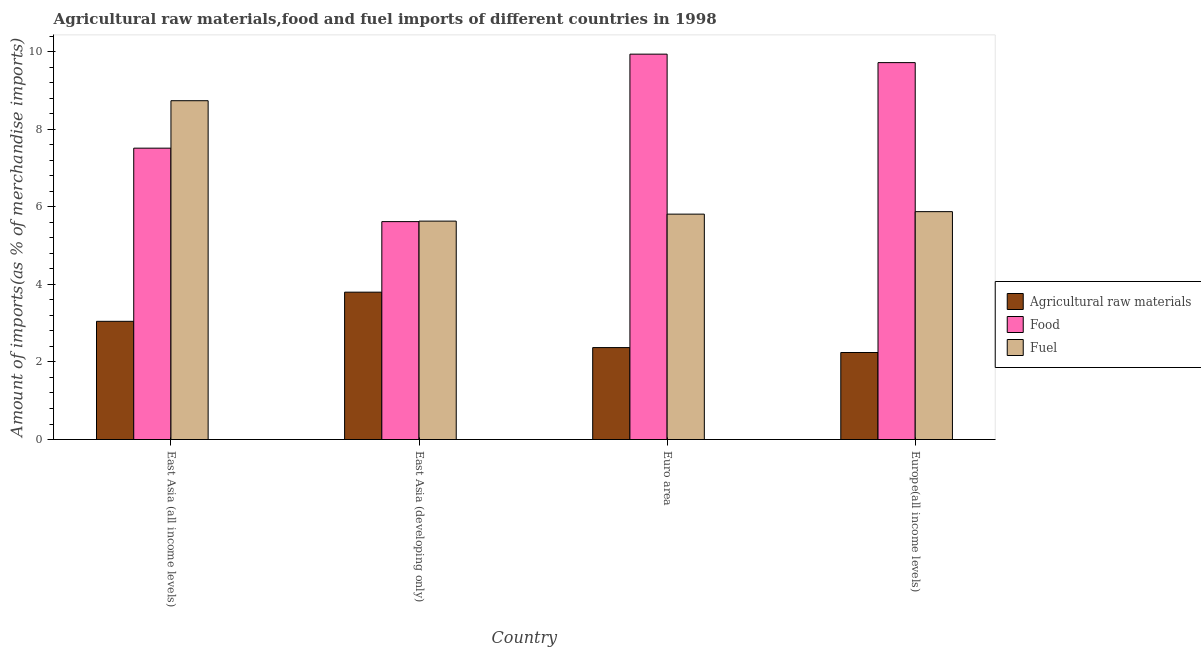How many different coloured bars are there?
Make the answer very short. 3. How many groups of bars are there?
Offer a very short reply. 4. Are the number of bars per tick equal to the number of legend labels?
Your answer should be very brief. Yes. Are the number of bars on each tick of the X-axis equal?
Provide a short and direct response. Yes. How many bars are there on the 4th tick from the left?
Give a very brief answer. 3. How many bars are there on the 2nd tick from the right?
Offer a very short reply. 3. What is the label of the 2nd group of bars from the left?
Your answer should be very brief. East Asia (developing only). What is the percentage of fuel imports in East Asia (all income levels)?
Offer a very short reply. 8.74. Across all countries, what is the maximum percentage of fuel imports?
Ensure brevity in your answer.  8.74. Across all countries, what is the minimum percentage of fuel imports?
Your answer should be compact. 5.63. In which country was the percentage of raw materials imports maximum?
Ensure brevity in your answer.  East Asia (developing only). In which country was the percentage of raw materials imports minimum?
Offer a very short reply. Europe(all income levels). What is the total percentage of food imports in the graph?
Offer a terse response. 32.8. What is the difference between the percentage of fuel imports in East Asia (all income levels) and that in East Asia (developing only)?
Your response must be concise. 3.11. What is the difference between the percentage of raw materials imports in East Asia (developing only) and the percentage of fuel imports in Europe(all income levels)?
Your answer should be very brief. -2.08. What is the average percentage of raw materials imports per country?
Your answer should be very brief. 2.87. What is the difference between the percentage of fuel imports and percentage of food imports in East Asia (developing only)?
Ensure brevity in your answer.  0.01. What is the ratio of the percentage of fuel imports in East Asia (all income levels) to that in East Asia (developing only)?
Give a very brief answer. 1.55. What is the difference between the highest and the second highest percentage of raw materials imports?
Provide a short and direct response. 0.75. What is the difference between the highest and the lowest percentage of raw materials imports?
Make the answer very short. 1.56. Is the sum of the percentage of food imports in East Asia (all income levels) and Euro area greater than the maximum percentage of fuel imports across all countries?
Your answer should be very brief. Yes. What does the 2nd bar from the left in East Asia (developing only) represents?
Make the answer very short. Food. What does the 1st bar from the right in Euro area represents?
Offer a very short reply. Fuel. Is it the case that in every country, the sum of the percentage of raw materials imports and percentage of food imports is greater than the percentage of fuel imports?
Give a very brief answer. Yes. How many bars are there?
Give a very brief answer. 12. Are all the bars in the graph horizontal?
Keep it short and to the point. No. What is the difference between two consecutive major ticks on the Y-axis?
Give a very brief answer. 2. Are the values on the major ticks of Y-axis written in scientific E-notation?
Ensure brevity in your answer.  No. Does the graph contain grids?
Give a very brief answer. No. How are the legend labels stacked?
Ensure brevity in your answer.  Vertical. What is the title of the graph?
Offer a very short reply. Agricultural raw materials,food and fuel imports of different countries in 1998. What is the label or title of the X-axis?
Offer a very short reply. Country. What is the label or title of the Y-axis?
Make the answer very short. Amount of imports(as % of merchandise imports). What is the Amount of imports(as % of merchandise imports) of Agricultural raw materials in East Asia (all income levels)?
Provide a short and direct response. 3.05. What is the Amount of imports(as % of merchandise imports) in Food in East Asia (all income levels)?
Ensure brevity in your answer.  7.52. What is the Amount of imports(as % of merchandise imports) of Fuel in East Asia (all income levels)?
Keep it short and to the point. 8.74. What is the Amount of imports(as % of merchandise imports) of Agricultural raw materials in East Asia (developing only)?
Give a very brief answer. 3.8. What is the Amount of imports(as % of merchandise imports) in Food in East Asia (developing only)?
Keep it short and to the point. 5.62. What is the Amount of imports(as % of merchandise imports) of Fuel in East Asia (developing only)?
Your answer should be very brief. 5.63. What is the Amount of imports(as % of merchandise imports) in Agricultural raw materials in Euro area?
Make the answer very short. 2.37. What is the Amount of imports(as % of merchandise imports) of Food in Euro area?
Ensure brevity in your answer.  9.94. What is the Amount of imports(as % of merchandise imports) of Fuel in Euro area?
Ensure brevity in your answer.  5.81. What is the Amount of imports(as % of merchandise imports) in Agricultural raw materials in Europe(all income levels)?
Your answer should be very brief. 2.24. What is the Amount of imports(as % of merchandise imports) in Food in Europe(all income levels)?
Your answer should be very brief. 9.72. What is the Amount of imports(as % of merchandise imports) of Fuel in Europe(all income levels)?
Provide a succinct answer. 5.88. Across all countries, what is the maximum Amount of imports(as % of merchandise imports) of Agricultural raw materials?
Make the answer very short. 3.8. Across all countries, what is the maximum Amount of imports(as % of merchandise imports) of Food?
Give a very brief answer. 9.94. Across all countries, what is the maximum Amount of imports(as % of merchandise imports) of Fuel?
Give a very brief answer. 8.74. Across all countries, what is the minimum Amount of imports(as % of merchandise imports) of Agricultural raw materials?
Offer a terse response. 2.24. Across all countries, what is the minimum Amount of imports(as % of merchandise imports) of Food?
Give a very brief answer. 5.62. Across all countries, what is the minimum Amount of imports(as % of merchandise imports) of Fuel?
Keep it short and to the point. 5.63. What is the total Amount of imports(as % of merchandise imports) of Agricultural raw materials in the graph?
Your response must be concise. 11.46. What is the total Amount of imports(as % of merchandise imports) of Food in the graph?
Offer a terse response. 32.8. What is the total Amount of imports(as % of merchandise imports) in Fuel in the graph?
Offer a very short reply. 26.06. What is the difference between the Amount of imports(as % of merchandise imports) in Agricultural raw materials in East Asia (all income levels) and that in East Asia (developing only)?
Your response must be concise. -0.75. What is the difference between the Amount of imports(as % of merchandise imports) in Food in East Asia (all income levels) and that in East Asia (developing only)?
Provide a succinct answer. 1.89. What is the difference between the Amount of imports(as % of merchandise imports) of Fuel in East Asia (all income levels) and that in East Asia (developing only)?
Provide a succinct answer. 3.11. What is the difference between the Amount of imports(as % of merchandise imports) in Agricultural raw materials in East Asia (all income levels) and that in Euro area?
Provide a short and direct response. 0.68. What is the difference between the Amount of imports(as % of merchandise imports) of Food in East Asia (all income levels) and that in Euro area?
Offer a terse response. -2.43. What is the difference between the Amount of imports(as % of merchandise imports) in Fuel in East Asia (all income levels) and that in Euro area?
Provide a succinct answer. 2.93. What is the difference between the Amount of imports(as % of merchandise imports) in Agricultural raw materials in East Asia (all income levels) and that in Europe(all income levels)?
Offer a terse response. 0.8. What is the difference between the Amount of imports(as % of merchandise imports) of Food in East Asia (all income levels) and that in Europe(all income levels)?
Give a very brief answer. -2.21. What is the difference between the Amount of imports(as % of merchandise imports) in Fuel in East Asia (all income levels) and that in Europe(all income levels)?
Ensure brevity in your answer.  2.86. What is the difference between the Amount of imports(as % of merchandise imports) of Agricultural raw materials in East Asia (developing only) and that in Euro area?
Offer a very short reply. 1.43. What is the difference between the Amount of imports(as % of merchandise imports) of Food in East Asia (developing only) and that in Euro area?
Provide a short and direct response. -4.32. What is the difference between the Amount of imports(as % of merchandise imports) of Fuel in East Asia (developing only) and that in Euro area?
Offer a very short reply. -0.18. What is the difference between the Amount of imports(as % of merchandise imports) of Agricultural raw materials in East Asia (developing only) and that in Europe(all income levels)?
Offer a very short reply. 1.56. What is the difference between the Amount of imports(as % of merchandise imports) in Food in East Asia (developing only) and that in Europe(all income levels)?
Your response must be concise. -4.1. What is the difference between the Amount of imports(as % of merchandise imports) of Fuel in East Asia (developing only) and that in Europe(all income levels)?
Give a very brief answer. -0.24. What is the difference between the Amount of imports(as % of merchandise imports) of Agricultural raw materials in Euro area and that in Europe(all income levels)?
Provide a succinct answer. 0.13. What is the difference between the Amount of imports(as % of merchandise imports) in Food in Euro area and that in Europe(all income levels)?
Make the answer very short. 0.22. What is the difference between the Amount of imports(as % of merchandise imports) of Fuel in Euro area and that in Europe(all income levels)?
Your answer should be compact. -0.06. What is the difference between the Amount of imports(as % of merchandise imports) of Agricultural raw materials in East Asia (all income levels) and the Amount of imports(as % of merchandise imports) of Food in East Asia (developing only)?
Give a very brief answer. -2.57. What is the difference between the Amount of imports(as % of merchandise imports) of Agricultural raw materials in East Asia (all income levels) and the Amount of imports(as % of merchandise imports) of Fuel in East Asia (developing only)?
Offer a very short reply. -2.58. What is the difference between the Amount of imports(as % of merchandise imports) in Food in East Asia (all income levels) and the Amount of imports(as % of merchandise imports) in Fuel in East Asia (developing only)?
Give a very brief answer. 1.88. What is the difference between the Amount of imports(as % of merchandise imports) of Agricultural raw materials in East Asia (all income levels) and the Amount of imports(as % of merchandise imports) of Food in Euro area?
Provide a short and direct response. -6.89. What is the difference between the Amount of imports(as % of merchandise imports) in Agricultural raw materials in East Asia (all income levels) and the Amount of imports(as % of merchandise imports) in Fuel in Euro area?
Provide a succinct answer. -2.77. What is the difference between the Amount of imports(as % of merchandise imports) in Food in East Asia (all income levels) and the Amount of imports(as % of merchandise imports) in Fuel in Euro area?
Offer a terse response. 1.7. What is the difference between the Amount of imports(as % of merchandise imports) of Agricultural raw materials in East Asia (all income levels) and the Amount of imports(as % of merchandise imports) of Food in Europe(all income levels)?
Provide a succinct answer. -6.67. What is the difference between the Amount of imports(as % of merchandise imports) of Agricultural raw materials in East Asia (all income levels) and the Amount of imports(as % of merchandise imports) of Fuel in Europe(all income levels)?
Offer a very short reply. -2.83. What is the difference between the Amount of imports(as % of merchandise imports) in Food in East Asia (all income levels) and the Amount of imports(as % of merchandise imports) in Fuel in Europe(all income levels)?
Your response must be concise. 1.64. What is the difference between the Amount of imports(as % of merchandise imports) of Agricultural raw materials in East Asia (developing only) and the Amount of imports(as % of merchandise imports) of Food in Euro area?
Provide a succinct answer. -6.14. What is the difference between the Amount of imports(as % of merchandise imports) in Agricultural raw materials in East Asia (developing only) and the Amount of imports(as % of merchandise imports) in Fuel in Euro area?
Make the answer very short. -2.01. What is the difference between the Amount of imports(as % of merchandise imports) in Food in East Asia (developing only) and the Amount of imports(as % of merchandise imports) in Fuel in Euro area?
Keep it short and to the point. -0.19. What is the difference between the Amount of imports(as % of merchandise imports) in Agricultural raw materials in East Asia (developing only) and the Amount of imports(as % of merchandise imports) in Food in Europe(all income levels)?
Make the answer very short. -5.92. What is the difference between the Amount of imports(as % of merchandise imports) of Agricultural raw materials in East Asia (developing only) and the Amount of imports(as % of merchandise imports) of Fuel in Europe(all income levels)?
Offer a terse response. -2.08. What is the difference between the Amount of imports(as % of merchandise imports) in Food in East Asia (developing only) and the Amount of imports(as % of merchandise imports) in Fuel in Europe(all income levels)?
Your response must be concise. -0.26. What is the difference between the Amount of imports(as % of merchandise imports) in Agricultural raw materials in Euro area and the Amount of imports(as % of merchandise imports) in Food in Europe(all income levels)?
Ensure brevity in your answer.  -7.35. What is the difference between the Amount of imports(as % of merchandise imports) in Agricultural raw materials in Euro area and the Amount of imports(as % of merchandise imports) in Fuel in Europe(all income levels)?
Offer a terse response. -3.51. What is the difference between the Amount of imports(as % of merchandise imports) in Food in Euro area and the Amount of imports(as % of merchandise imports) in Fuel in Europe(all income levels)?
Your answer should be compact. 4.06. What is the average Amount of imports(as % of merchandise imports) in Agricultural raw materials per country?
Keep it short and to the point. 2.87. What is the average Amount of imports(as % of merchandise imports) of Food per country?
Offer a terse response. 8.2. What is the average Amount of imports(as % of merchandise imports) in Fuel per country?
Provide a short and direct response. 6.52. What is the difference between the Amount of imports(as % of merchandise imports) in Agricultural raw materials and Amount of imports(as % of merchandise imports) in Food in East Asia (all income levels)?
Give a very brief answer. -4.47. What is the difference between the Amount of imports(as % of merchandise imports) in Agricultural raw materials and Amount of imports(as % of merchandise imports) in Fuel in East Asia (all income levels)?
Ensure brevity in your answer.  -5.69. What is the difference between the Amount of imports(as % of merchandise imports) of Food and Amount of imports(as % of merchandise imports) of Fuel in East Asia (all income levels)?
Give a very brief answer. -1.22. What is the difference between the Amount of imports(as % of merchandise imports) in Agricultural raw materials and Amount of imports(as % of merchandise imports) in Food in East Asia (developing only)?
Offer a terse response. -1.82. What is the difference between the Amount of imports(as % of merchandise imports) in Agricultural raw materials and Amount of imports(as % of merchandise imports) in Fuel in East Asia (developing only)?
Give a very brief answer. -1.83. What is the difference between the Amount of imports(as % of merchandise imports) in Food and Amount of imports(as % of merchandise imports) in Fuel in East Asia (developing only)?
Give a very brief answer. -0.01. What is the difference between the Amount of imports(as % of merchandise imports) in Agricultural raw materials and Amount of imports(as % of merchandise imports) in Food in Euro area?
Offer a very short reply. -7.57. What is the difference between the Amount of imports(as % of merchandise imports) in Agricultural raw materials and Amount of imports(as % of merchandise imports) in Fuel in Euro area?
Your response must be concise. -3.44. What is the difference between the Amount of imports(as % of merchandise imports) of Food and Amount of imports(as % of merchandise imports) of Fuel in Euro area?
Provide a succinct answer. 4.13. What is the difference between the Amount of imports(as % of merchandise imports) of Agricultural raw materials and Amount of imports(as % of merchandise imports) of Food in Europe(all income levels)?
Ensure brevity in your answer.  -7.48. What is the difference between the Amount of imports(as % of merchandise imports) in Agricultural raw materials and Amount of imports(as % of merchandise imports) in Fuel in Europe(all income levels)?
Offer a terse response. -3.63. What is the difference between the Amount of imports(as % of merchandise imports) in Food and Amount of imports(as % of merchandise imports) in Fuel in Europe(all income levels)?
Offer a very short reply. 3.84. What is the ratio of the Amount of imports(as % of merchandise imports) of Agricultural raw materials in East Asia (all income levels) to that in East Asia (developing only)?
Offer a terse response. 0.8. What is the ratio of the Amount of imports(as % of merchandise imports) in Food in East Asia (all income levels) to that in East Asia (developing only)?
Keep it short and to the point. 1.34. What is the ratio of the Amount of imports(as % of merchandise imports) of Fuel in East Asia (all income levels) to that in East Asia (developing only)?
Give a very brief answer. 1.55. What is the ratio of the Amount of imports(as % of merchandise imports) of Agricultural raw materials in East Asia (all income levels) to that in Euro area?
Provide a succinct answer. 1.29. What is the ratio of the Amount of imports(as % of merchandise imports) of Food in East Asia (all income levels) to that in Euro area?
Your answer should be very brief. 0.76. What is the ratio of the Amount of imports(as % of merchandise imports) in Fuel in East Asia (all income levels) to that in Euro area?
Make the answer very short. 1.5. What is the ratio of the Amount of imports(as % of merchandise imports) of Agricultural raw materials in East Asia (all income levels) to that in Europe(all income levels)?
Your answer should be very brief. 1.36. What is the ratio of the Amount of imports(as % of merchandise imports) of Food in East Asia (all income levels) to that in Europe(all income levels)?
Offer a terse response. 0.77. What is the ratio of the Amount of imports(as % of merchandise imports) in Fuel in East Asia (all income levels) to that in Europe(all income levels)?
Your answer should be very brief. 1.49. What is the ratio of the Amount of imports(as % of merchandise imports) of Agricultural raw materials in East Asia (developing only) to that in Euro area?
Offer a terse response. 1.6. What is the ratio of the Amount of imports(as % of merchandise imports) of Food in East Asia (developing only) to that in Euro area?
Make the answer very short. 0.57. What is the ratio of the Amount of imports(as % of merchandise imports) of Fuel in East Asia (developing only) to that in Euro area?
Ensure brevity in your answer.  0.97. What is the ratio of the Amount of imports(as % of merchandise imports) in Agricultural raw materials in East Asia (developing only) to that in Europe(all income levels)?
Offer a very short reply. 1.69. What is the ratio of the Amount of imports(as % of merchandise imports) of Food in East Asia (developing only) to that in Europe(all income levels)?
Give a very brief answer. 0.58. What is the ratio of the Amount of imports(as % of merchandise imports) in Fuel in East Asia (developing only) to that in Europe(all income levels)?
Provide a short and direct response. 0.96. What is the ratio of the Amount of imports(as % of merchandise imports) of Agricultural raw materials in Euro area to that in Europe(all income levels)?
Your answer should be very brief. 1.06. What is the ratio of the Amount of imports(as % of merchandise imports) in Food in Euro area to that in Europe(all income levels)?
Your response must be concise. 1.02. What is the ratio of the Amount of imports(as % of merchandise imports) in Fuel in Euro area to that in Europe(all income levels)?
Keep it short and to the point. 0.99. What is the difference between the highest and the second highest Amount of imports(as % of merchandise imports) of Agricultural raw materials?
Provide a short and direct response. 0.75. What is the difference between the highest and the second highest Amount of imports(as % of merchandise imports) of Food?
Make the answer very short. 0.22. What is the difference between the highest and the second highest Amount of imports(as % of merchandise imports) of Fuel?
Make the answer very short. 2.86. What is the difference between the highest and the lowest Amount of imports(as % of merchandise imports) in Agricultural raw materials?
Ensure brevity in your answer.  1.56. What is the difference between the highest and the lowest Amount of imports(as % of merchandise imports) of Food?
Ensure brevity in your answer.  4.32. What is the difference between the highest and the lowest Amount of imports(as % of merchandise imports) in Fuel?
Give a very brief answer. 3.11. 